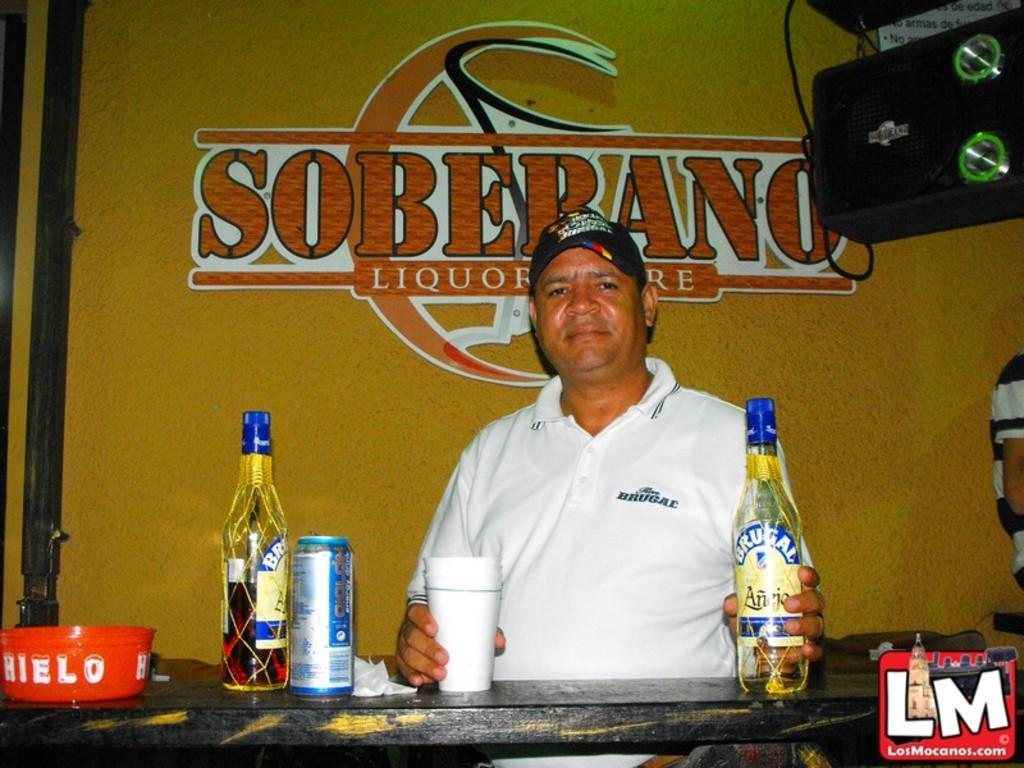<image>
Describe the image concisely. A man stands in front of a sing that says Soberano Liquor and holds a bottle of Brugal. 